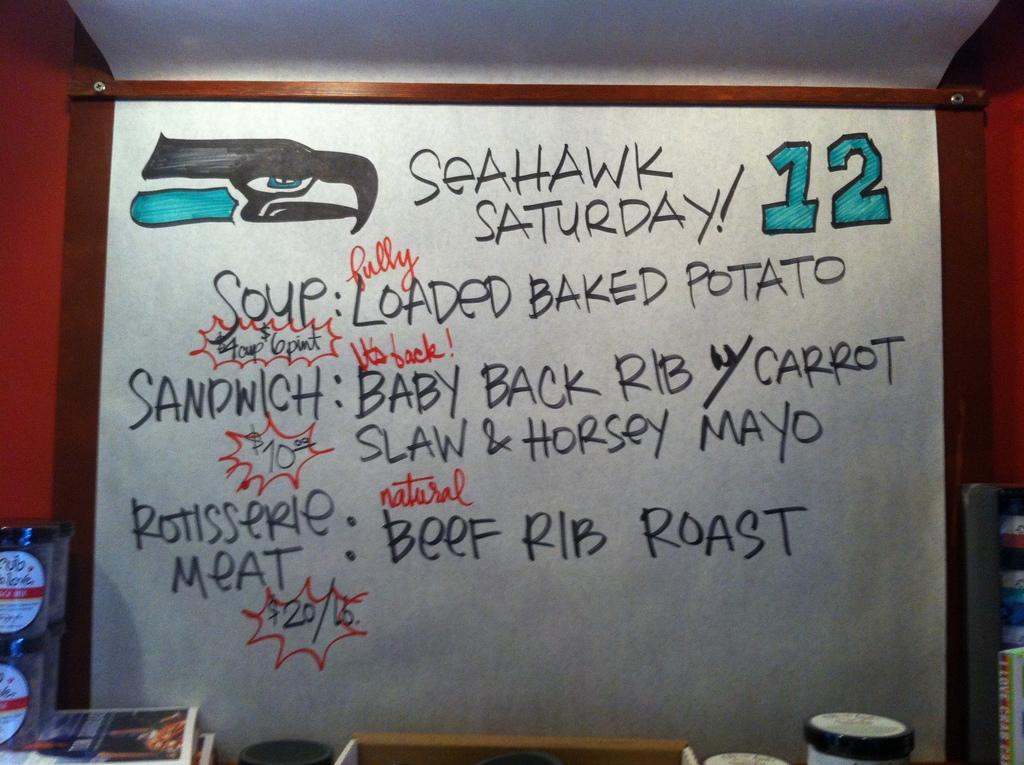<image>
Relay a brief, clear account of the picture shown. A chalk board that says Sea hawk saturday with the number twelve on the right side. 